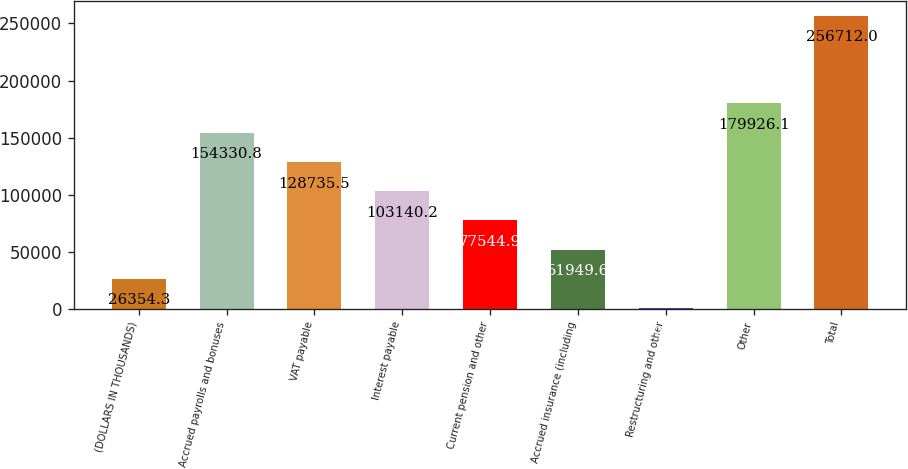<chart> <loc_0><loc_0><loc_500><loc_500><bar_chart><fcel>(DOLLARS IN THOUSANDS)<fcel>Accrued payrolls and bonuses<fcel>VAT payable<fcel>Interest payable<fcel>Current pension and other<fcel>Accrued insurance (including<fcel>Restructuring and other<fcel>Other<fcel>Total<nl><fcel>26354.3<fcel>154331<fcel>128736<fcel>103140<fcel>77544.9<fcel>51949.6<fcel>759<fcel>179926<fcel>256712<nl></chart> 